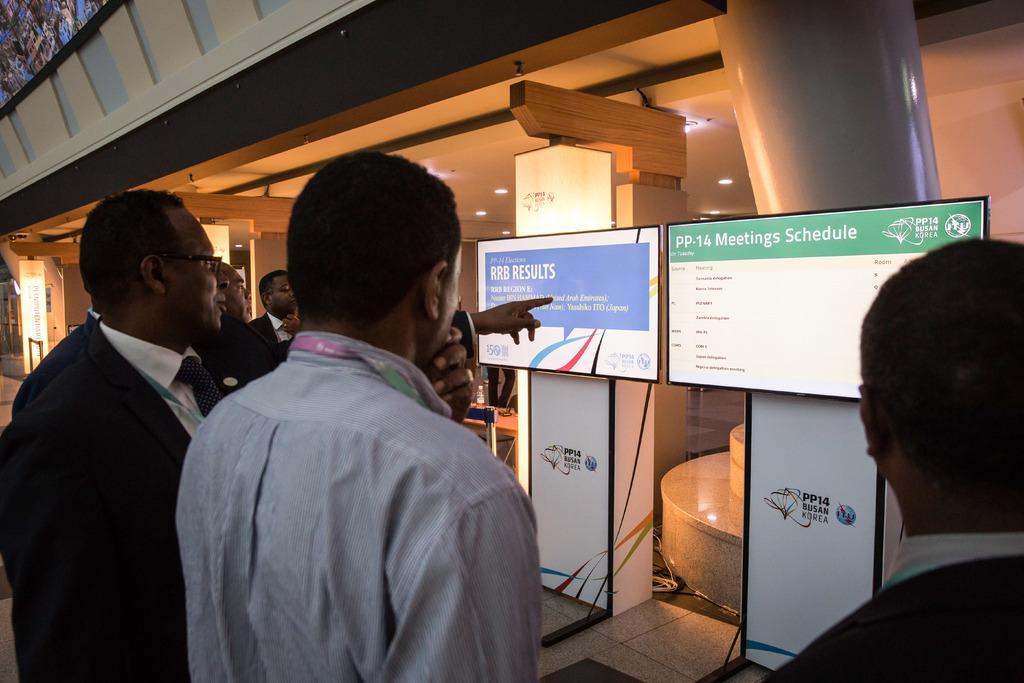Describe this image in one or two sentences. In the center of the image we can see people standing. In the background there are screens and there are walls. At the top there are lights. 